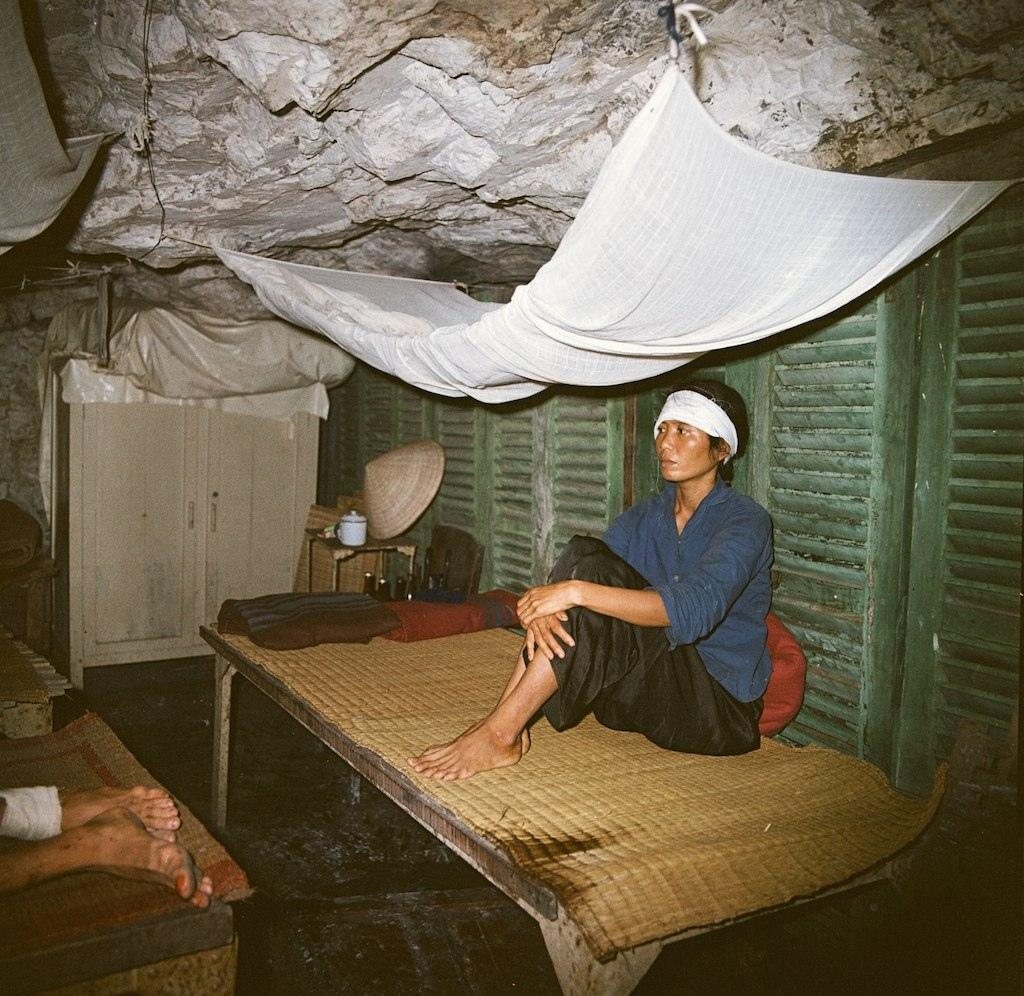What is the man in the image doing? The man is sitting on a cot in the image. What other furniture can be seen in the image? There is a cupboard in the image. What items are visible on the cot? There are beverage bottles and a hat on the cot in the image. Who else is present in the image? There is another person lying on the cot in the image. What type of star can be seen shining brightly in the image? There is no star visible in the image; it is an indoor setting with no celestial objects present. 